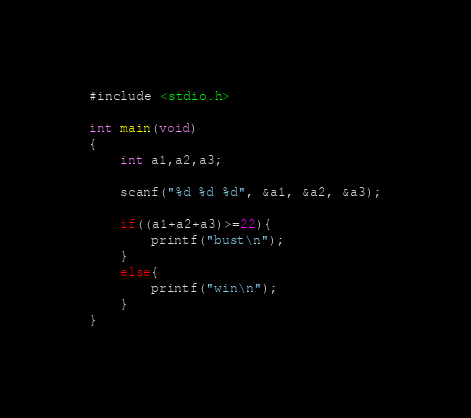Convert code to text. <code><loc_0><loc_0><loc_500><loc_500><_C_>#include <stdio.h>

int main(void)
{
    int a1,a2,a3;

    scanf("%d %d %d", &a1, &a2, &a3);

    if((a1+a2+a3)>=22){
        printf("bust\n");
    }
    else{
        printf("win\n");
    }
}</code> 